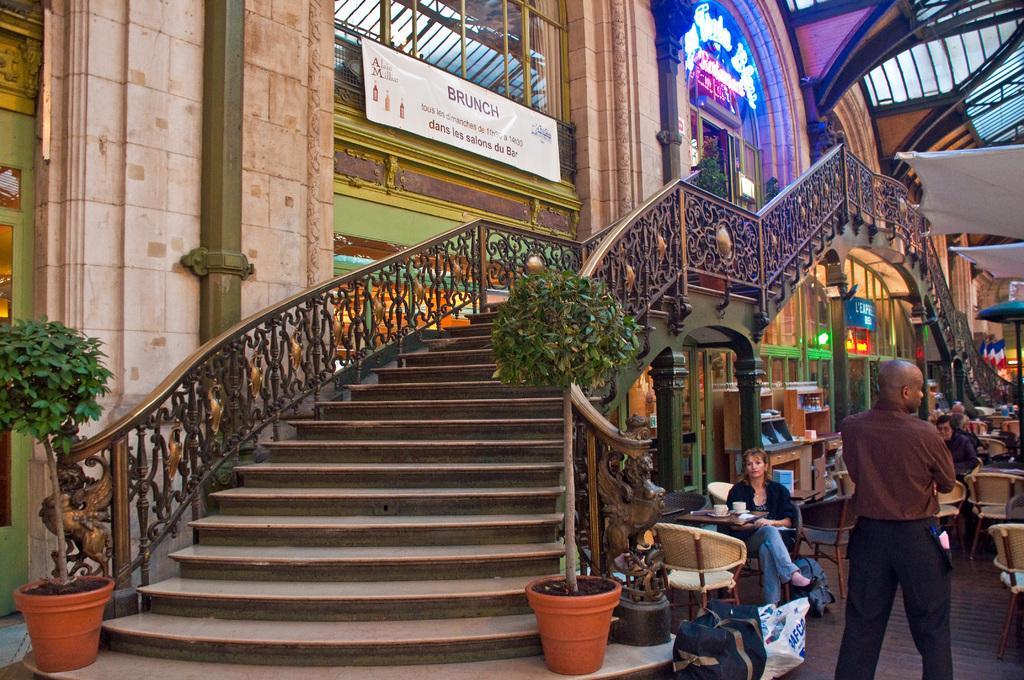How would you summarize this image in a sentence or two? In this picture we can see a man is standing on the floor and in front of the man there are groups of people sitting on chairs and tables and on the table there are cups. On the left side of the people there is a staircase, house plants and a wall with a banner. 